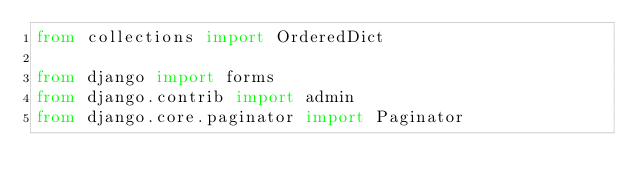<code> <loc_0><loc_0><loc_500><loc_500><_Python_>from collections import OrderedDict

from django import forms
from django.contrib import admin
from django.core.paginator import Paginator</code> 